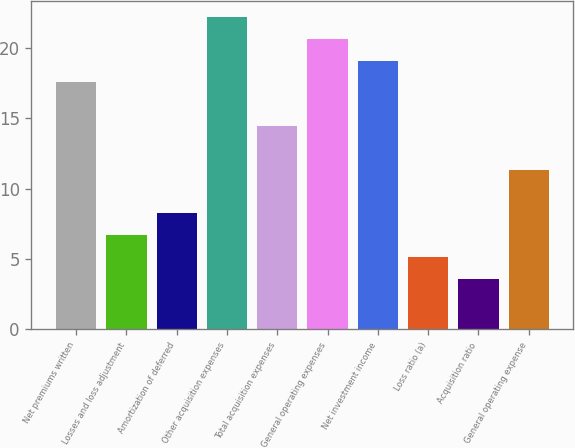Convert chart to OTSL. <chart><loc_0><loc_0><loc_500><loc_500><bar_chart><fcel>Net premiums written<fcel>Losses and loss adjustment<fcel>Amortization of deferred<fcel>Other acquisition expenses<fcel>Total acquisition expenses<fcel>General operating expenses<fcel>Net investment income<fcel>Loss ratio (a)<fcel>Acquisition ratio<fcel>General operating expense<nl><fcel>17.55<fcel>6.7<fcel>8.25<fcel>22.2<fcel>14.45<fcel>20.65<fcel>19.1<fcel>5.15<fcel>3.6<fcel>11.35<nl></chart> 